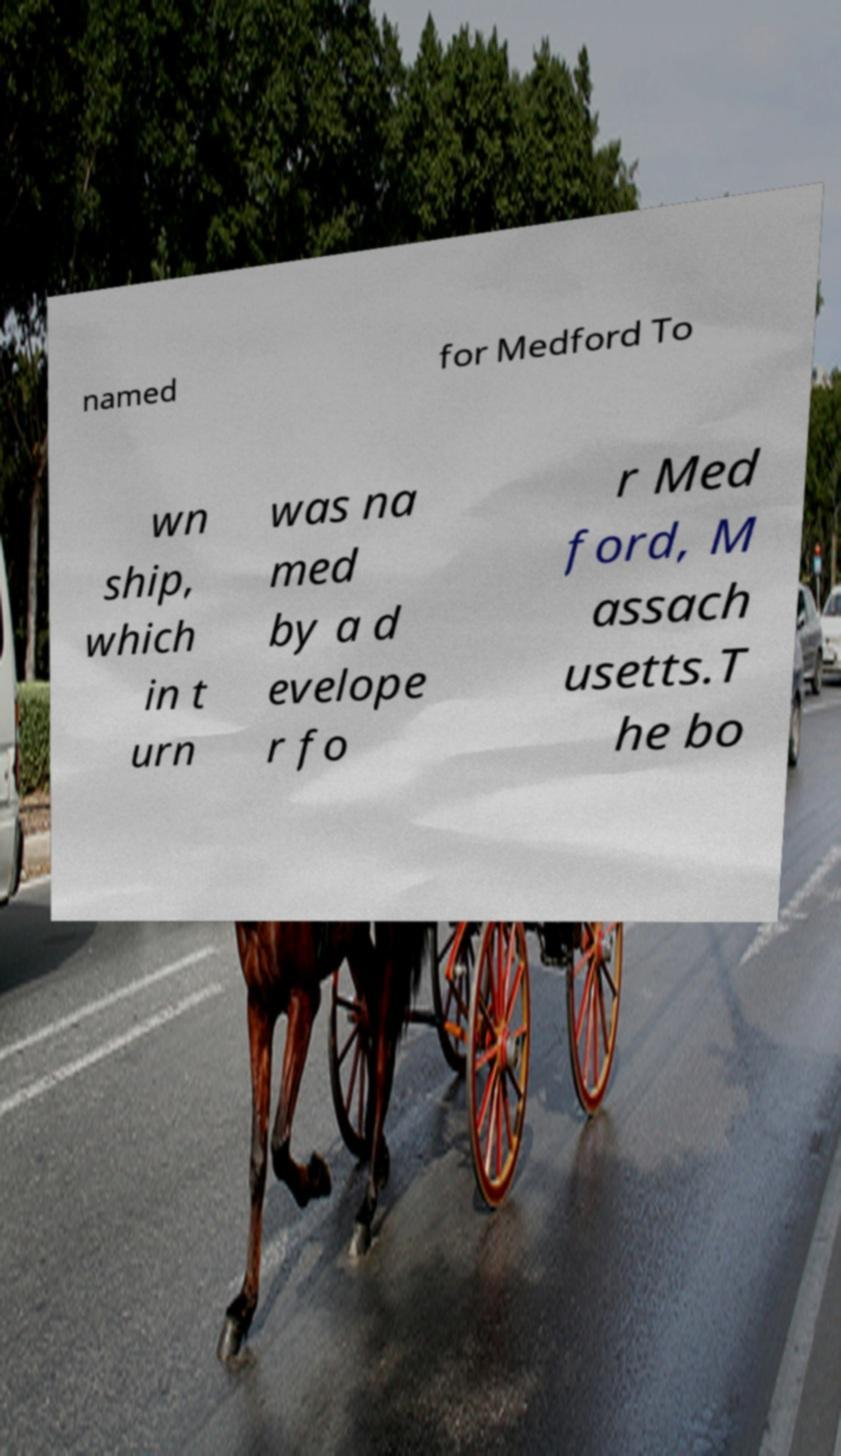Could you assist in decoding the text presented in this image and type it out clearly? named for Medford To wn ship, which in t urn was na med by a d evelope r fo r Med ford, M assach usetts.T he bo 